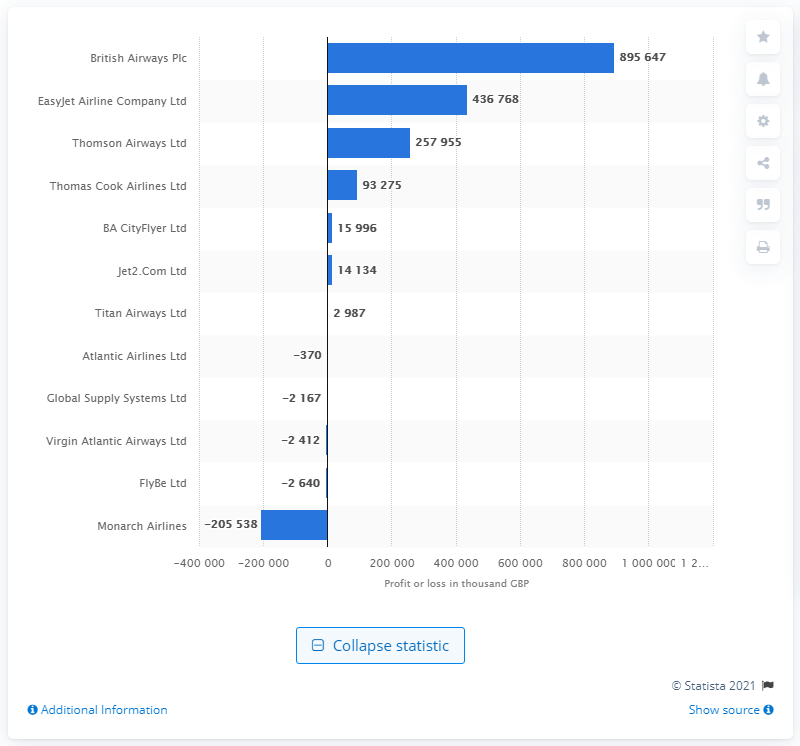Give some essential details in this illustration. In 2014/2015, Monarch Airlines had the highest operating losses among all airlines. 